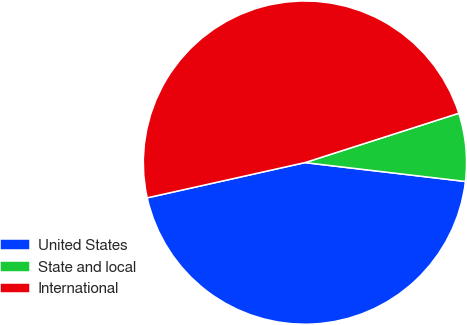Convert chart to OTSL. <chart><loc_0><loc_0><loc_500><loc_500><pie_chart><fcel>United States<fcel>State and local<fcel>International<nl><fcel>44.64%<fcel>6.8%<fcel>48.56%<nl></chart> 